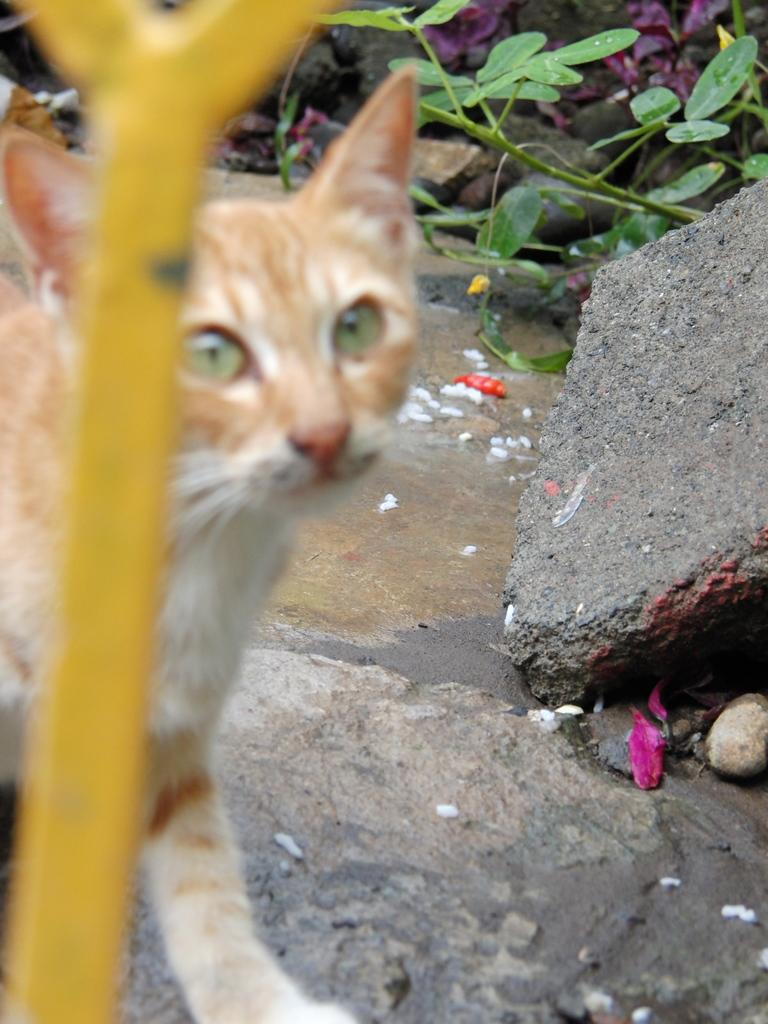What animal is present in the image? There is a cat in the image. What is the cat standing on? The cat is standing on a stone. What type of plants can be seen in the image? There are flowers and leaves in the image. Where is the pipe located in the image? The pipe is on the left side of the image. What type of impulse does the cat experience when it sees the crow in the image? There is no crow present in the image, so the cat does not experience any impulse related to a crow. 